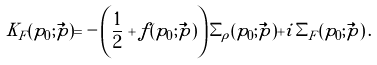<formula> <loc_0><loc_0><loc_500><loc_500>K _ { F } ( p _ { 0 } ; \vec { p } ) = - \left ( \frac { 1 } { 2 } + f ( p _ { 0 } ; \vec { p } ) \right ) \Sigma _ { \rho } ( p _ { 0 } ; \vec { p } ) + i \, \Sigma _ { F } ( p _ { 0 } ; \vec { p } ) \, .</formula> 